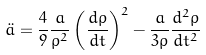Convert formula to latex. <formula><loc_0><loc_0><loc_500><loc_500>\ddot { a } = \frac { 4 } { 9 } \frac { a } { \rho ^ { 2 } } \left ( { \frac { d \rho } { d t } } \right ) ^ { 2 } - \frac { a } { 3 \rho } \frac { d ^ { 2 } \rho } { d t ^ { 2 } }</formula> 